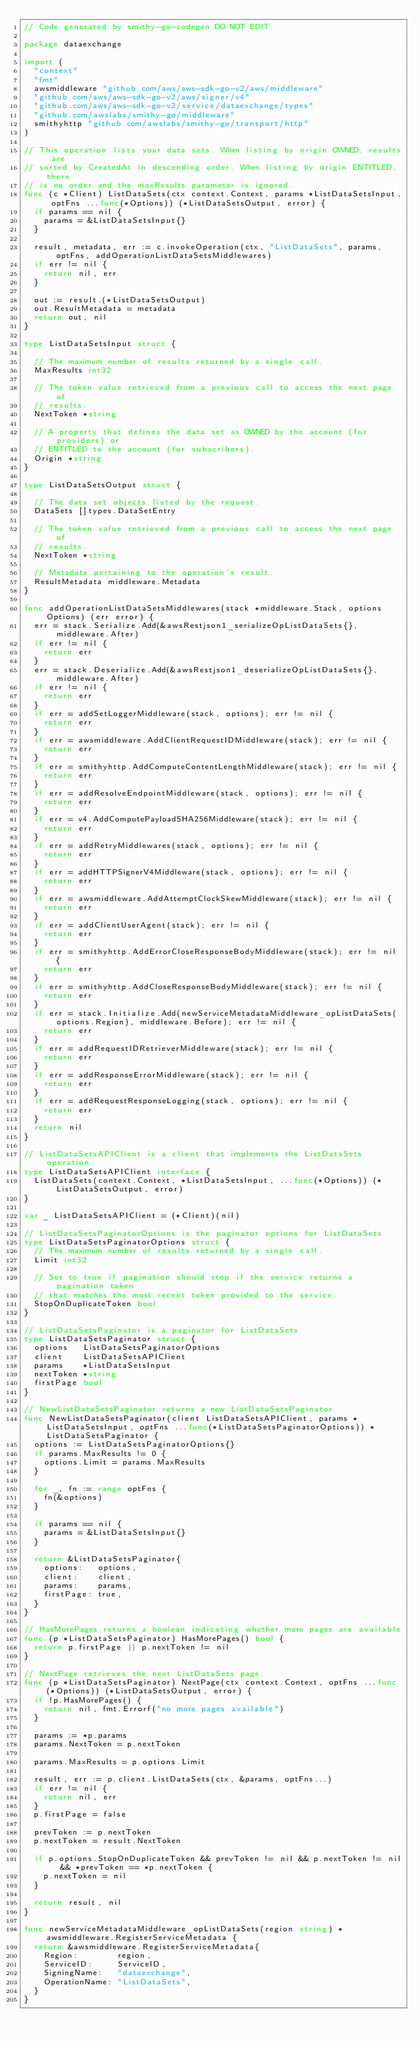<code> <loc_0><loc_0><loc_500><loc_500><_Go_>// Code generated by smithy-go-codegen DO NOT EDIT.

package dataexchange

import (
	"context"
	"fmt"
	awsmiddleware "github.com/aws/aws-sdk-go-v2/aws/middleware"
	"github.com/aws/aws-sdk-go-v2/aws/signer/v4"
	"github.com/aws/aws-sdk-go-v2/service/dataexchange/types"
	"github.com/awslabs/smithy-go/middleware"
	smithyhttp "github.com/awslabs/smithy-go/transport/http"
)

// This operation lists your data sets. When listing by origin OWNED, results are
// sorted by CreatedAt in descending order. When listing by origin ENTITLED, there
// is no order and the maxResults parameter is ignored.
func (c *Client) ListDataSets(ctx context.Context, params *ListDataSetsInput, optFns ...func(*Options)) (*ListDataSetsOutput, error) {
	if params == nil {
		params = &ListDataSetsInput{}
	}

	result, metadata, err := c.invokeOperation(ctx, "ListDataSets", params, optFns, addOperationListDataSetsMiddlewares)
	if err != nil {
		return nil, err
	}

	out := result.(*ListDataSetsOutput)
	out.ResultMetadata = metadata
	return out, nil
}

type ListDataSetsInput struct {

	// The maximum number of results returned by a single call.
	MaxResults int32

	// The token value retrieved from a previous call to access the next page of
	// results.
	NextToken *string

	// A property that defines the data set as OWNED by the account (for providers) or
	// ENTITLED to the account (for subscribers).
	Origin *string
}

type ListDataSetsOutput struct {

	// The data set objects listed by the request.
	DataSets []types.DataSetEntry

	// The token value retrieved from a previous call to access the next page of
	// results.
	NextToken *string

	// Metadata pertaining to the operation's result.
	ResultMetadata middleware.Metadata
}

func addOperationListDataSetsMiddlewares(stack *middleware.Stack, options Options) (err error) {
	err = stack.Serialize.Add(&awsRestjson1_serializeOpListDataSets{}, middleware.After)
	if err != nil {
		return err
	}
	err = stack.Deserialize.Add(&awsRestjson1_deserializeOpListDataSets{}, middleware.After)
	if err != nil {
		return err
	}
	if err = addSetLoggerMiddleware(stack, options); err != nil {
		return err
	}
	if err = awsmiddleware.AddClientRequestIDMiddleware(stack); err != nil {
		return err
	}
	if err = smithyhttp.AddComputeContentLengthMiddleware(stack); err != nil {
		return err
	}
	if err = addResolveEndpointMiddleware(stack, options); err != nil {
		return err
	}
	if err = v4.AddComputePayloadSHA256Middleware(stack); err != nil {
		return err
	}
	if err = addRetryMiddlewares(stack, options); err != nil {
		return err
	}
	if err = addHTTPSignerV4Middleware(stack, options); err != nil {
		return err
	}
	if err = awsmiddleware.AddAttemptClockSkewMiddleware(stack); err != nil {
		return err
	}
	if err = addClientUserAgent(stack); err != nil {
		return err
	}
	if err = smithyhttp.AddErrorCloseResponseBodyMiddleware(stack); err != nil {
		return err
	}
	if err = smithyhttp.AddCloseResponseBodyMiddleware(stack); err != nil {
		return err
	}
	if err = stack.Initialize.Add(newServiceMetadataMiddleware_opListDataSets(options.Region), middleware.Before); err != nil {
		return err
	}
	if err = addRequestIDRetrieverMiddleware(stack); err != nil {
		return err
	}
	if err = addResponseErrorMiddleware(stack); err != nil {
		return err
	}
	if err = addRequestResponseLogging(stack, options); err != nil {
		return err
	}
	return nil
}

// ListDataSetsAPIClient is a client that implements the ListDataSets operation.
type ListDataSetsAPIClient interface {
	ListDataSets(context.Context, *ListDataSetsInput, ...func(*Options)) (*ListDataSetsOutput, error)
}

var _ ListDataSetsAPIClient = (*Client)(nil)

// ListDataSetsPaginatorOptions is the paginator options for ListDataSets
type ListDataSetsPaginatorOptions struct {
	// The maximum number of results returned by a single call.
	Limit int32

	// Set to true if pagination should stop if the service returns a pagination token
	// that matches the most recent token provided to the service.
	StopOnDuplicateToken bool
}

// ListDataSetsPaginator is a paginator for ListDataSets
type ListDataSetsPaginator struct {
	options   ListDataSetsPaginatorOptions
	client    ListDataSetsAPIClient
	params    *ListDataSetsInput
	nextToken *string
	firstPage bool
}

// NewListDataSetsPaginator returns a new ListDataSetsPaginator
func NewListDataSetsPaginator(client ListDataSetsAPIClient, params *ListDataSetsInput, optFns ...func(*ListDataSetsPaginatorOptions)) *ListDataSetsPaginator {
	options := ListDataSetsPaginatorOptions{}
	if params.MaxResults != 0 {
		options.Limit = params.MaxResults
	}

	for _, fn := range optFns {
		fn(&options)
	}

	if params == nil {
		params = &ListDataSetsInput{}
	}

	return &ListDataSetsPaginator{
		options:   options,
		client:    client,
		params:    params,
		firstPage: true,
	}
}

// HasMorePages returns a boolean indicating whether more pages are available
func (p *ListDataSetsPaginator) HasMorePages() bool {
	return p.firstPage || p.nextToken != nil
}

// NextPage retrieves the next ListDataSets page.
func (p *ListDataSetsPaginator) NextPage(ctx context.Context, optFns ...func(*Options)) (*ListDataSetsOutput, error) {
	if !p.HasMorePages() {
		return nil, fmt.Errorf("no more pages available")
	}

	params := *p.params
	params.NextToken = p.nextToken

	params.MaxResults = p.options.Limit

	result, err := p.client.ListDataSets(ctx, &params, optFns...)
	if err != nil {
		return nil, err
	}
	p.firstPage = false

	prevToken := p.nextToken
	p.nextToken = result.NextToken

	if p.options.StopOnDuplicateToken && prevToken != nil && p.nextToken != nil && *prevToken == *p.nextToken {
		p.nextToken = nil
	}

	return result, nil
}

func newServiceMetadataMiddleware_opListDataSets(region string) *awsmiddleware.RegisterServiceMetadata {
	return &awsmiddleware.RegisterServiceMetadata{
		Region:        region,
		ServiceID:     ServiceID,
		SigningName:   "dataexchange",
		OperationName: "ListDataSets",
	}
}
</code> 